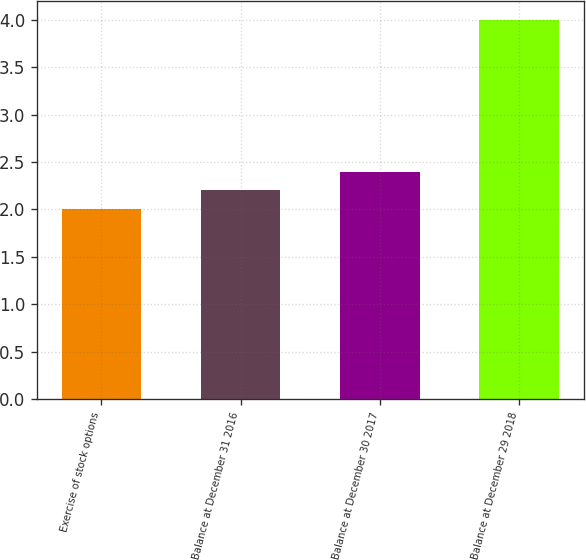Convert chart to OTSL. <chart><loc_0><loc_0><loc_500><loc_500><bar_chart><fcel>Exercise of stock options<fcel>Balance at December 31 2016<fcel>Balance at December 30 2017<fcel>Balance at December 29 2018<nl><fcel>2<fcel>2.2<fcel>2.4<fcel>4<nl></chart> 